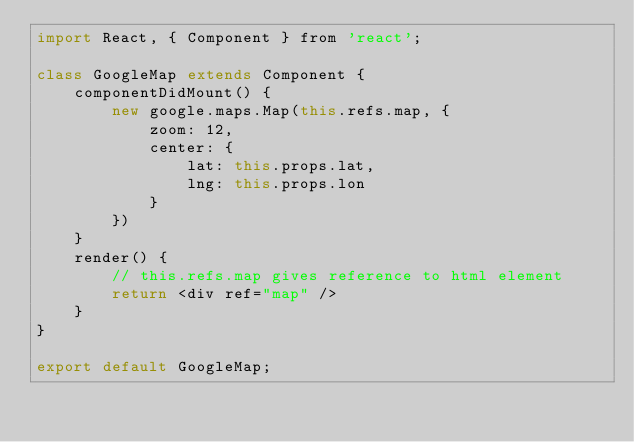<code> <loc_0><loc_0><loc_500><loc_500><_JavaScript_>import React, { Component } from 'react';

class GoogleMap extends Component {
	componentDidMount() {
		new google.maps.Map(this.refs.map, {
			zoom: 12,
			center: {
				lat: this.props.lat,
				lng: this.props.lon
			}
		})
	}
	render() {
		// this.refs.map gives reference to html element
		return <div ref="map" />
	}
}

export default GoogleMap;</code> 